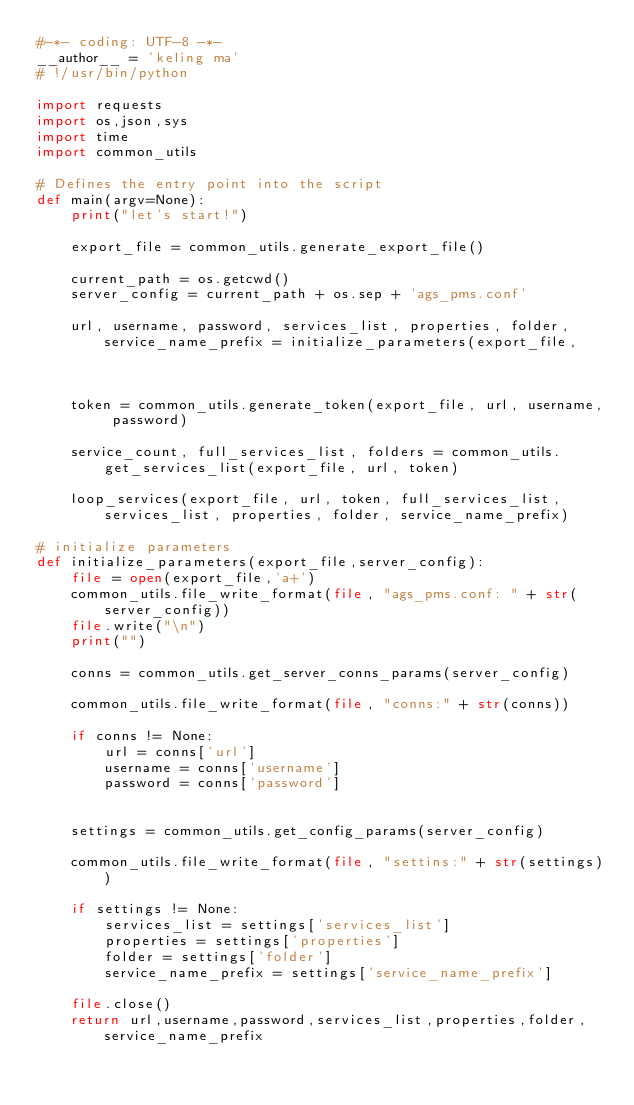<code> <loc_0><loc_0><loc_500><loc_500><_Python_>#-*- coding: UTF-8 -*-
__author__ = 'keling ma'
# !/usr/bin/python

import requests
import os,json,sys
import time
import common_utils

# Defines the entry point into the script
def main(argv=None):
    print("let's start!")

    export_file = common_utils.generate_export_file()

    current_path = os.getcwd()
    server_config = current_path + os.sep + 'ags_pms.conf'

    url, username, password, services_list, properties, folder, service_name_prefix = initialize_parameters(export_file,
                                                                                                server_config)
    token = common_utils.generate_token(export_file, url, username, password)

    service_count, full_services_list, folders = common_utils.get_services_list(export_file, url, token)

    loop_services(export_file, url, token, full_services_list, services_list, properties, folder, service_name_prefix)

# initialize parameters
def initialize_parameters(export_file,server_config):
    file = open(export_file,'a+')
    common_utils.file_write_format(file, "ags_pms.conf: " + str(server_config))
    file.write("\n")
    print("")

    conns = common_utils.get_server_conns_params(server_config)

    common_utils.file_write_format(file, "conns:" + str(conns))

    if conns != None:
        url = conns['url']
        username = conns['username']
        password = conns['password']


    settings = common_utils.get_config_params(server_config)

    common_utils.file_write_format(file, "settins:" + str(settings))

    if settings != None:
        services_list = settings['services_list']
        properties = settings['properties']
        folder = settings['folder']
        service_name_prefix = settings['service_name_prefix']

    file.close()
    return url,username,password,services_list,properties,folder,service_name_prefix
</code> 